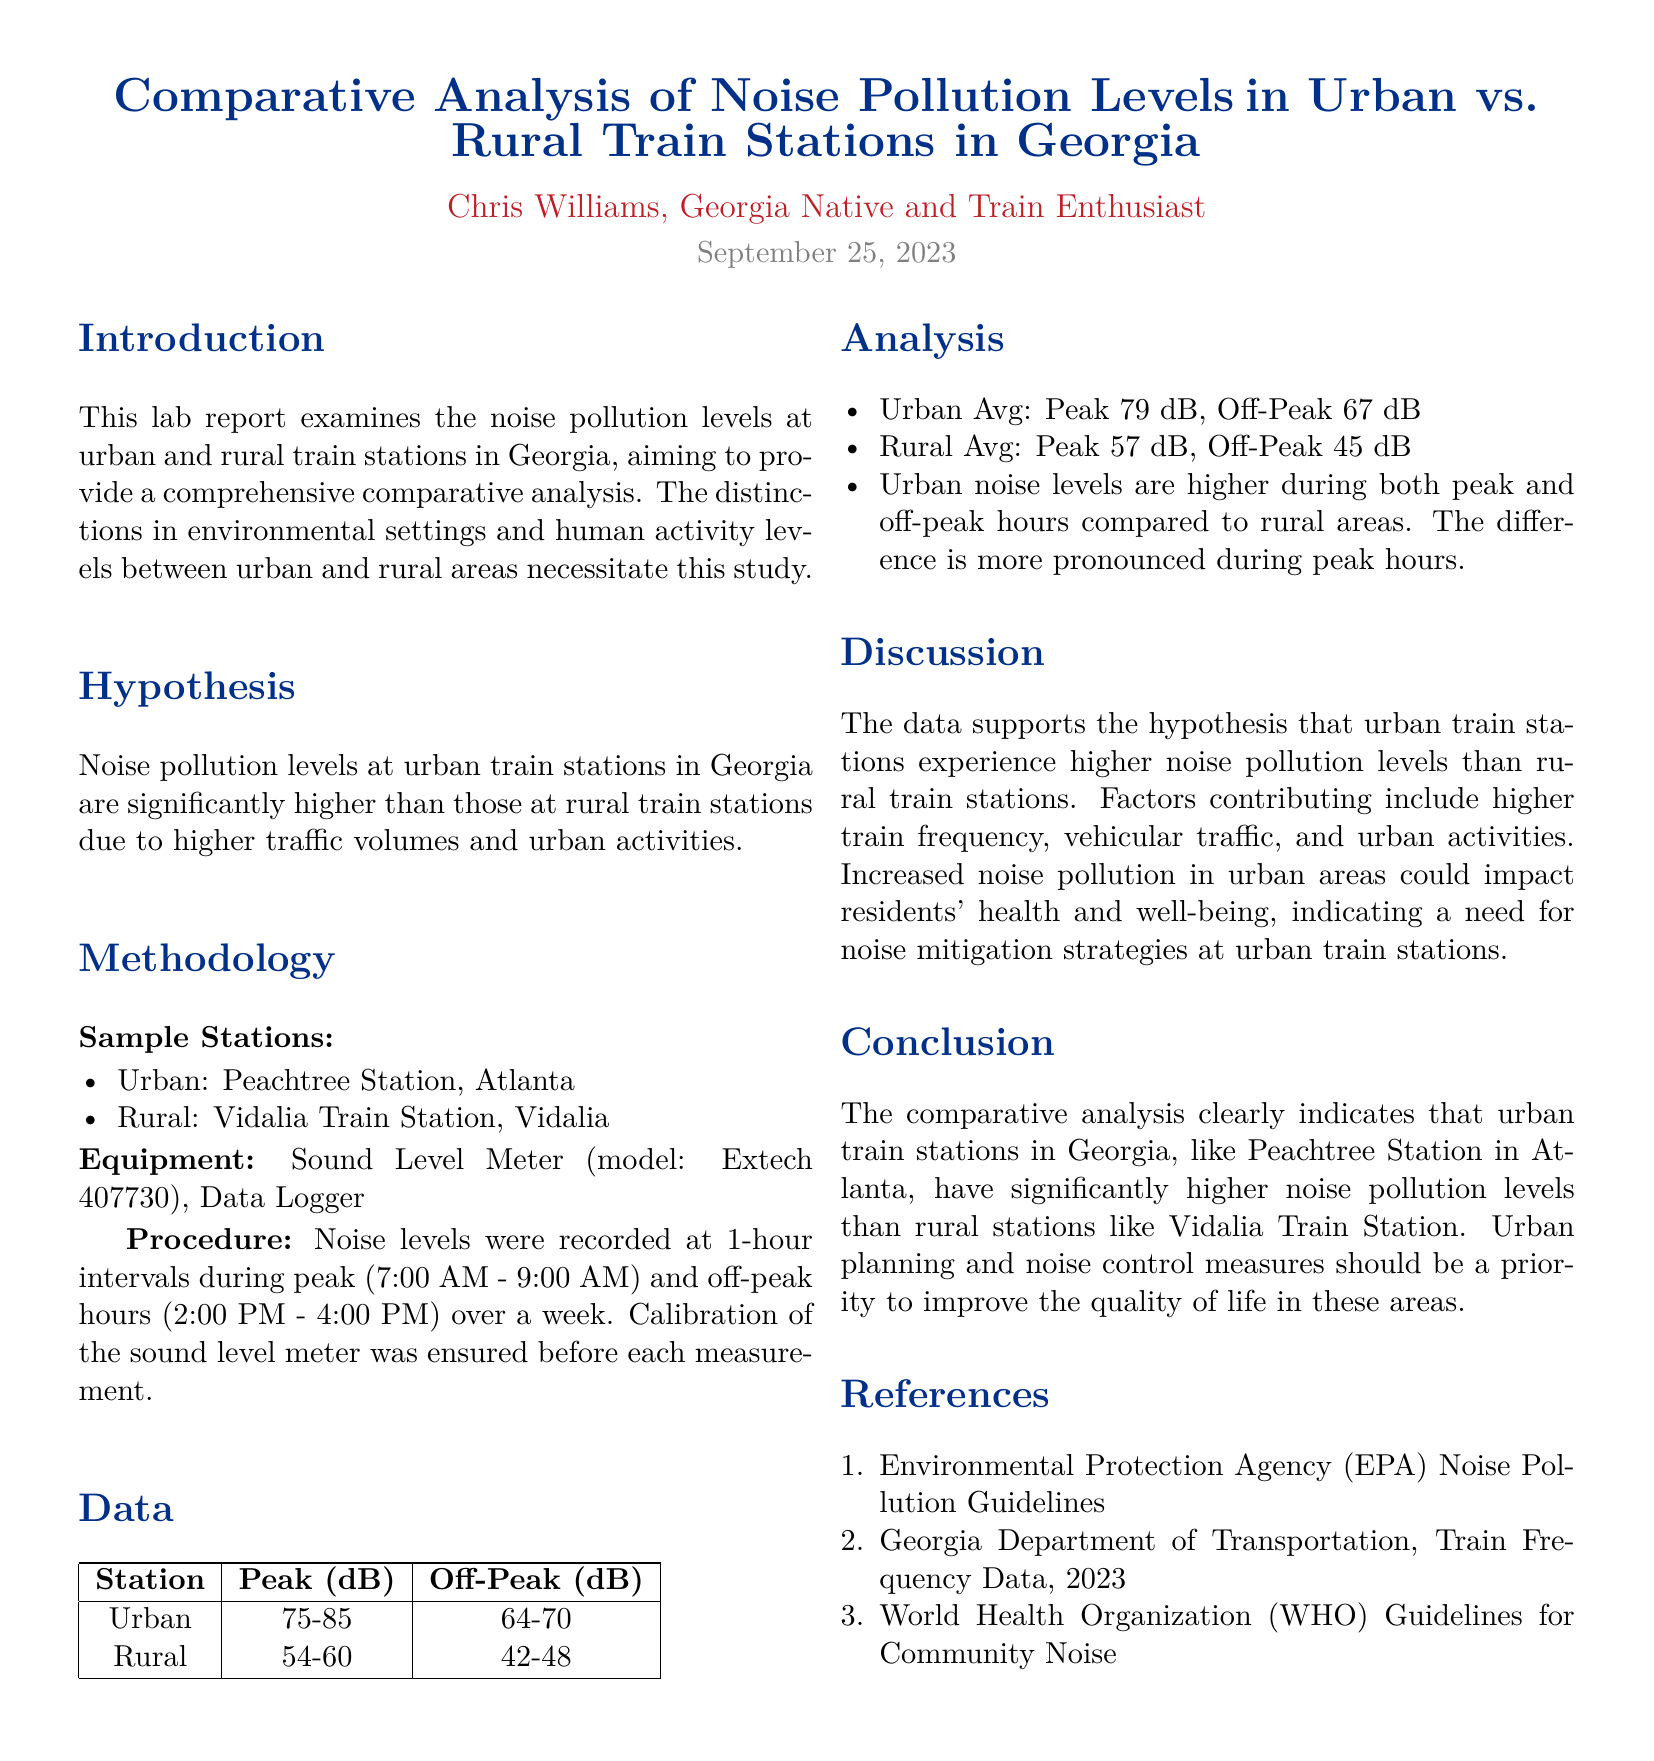What is the title of the lab report? The title summarizes the main focus of the report on noise pollution levels in different train stations in Georgia.
Answer: Comparative Analysis of Noise Pollution Levels in Urban vs. Rural Train Stations in Georgia Who authored the lab report? The document lists the author at the top, indicating their identity and interest in trains.
Answer: Chris Williams What is the date of the lab report? The date in the document indicates when the report was completed.
Answer: September 25, 2023 What was the peak noise level recorded at urban stations? The document provides specific dB ranges under the Data section.
Answer: 75-85 What was the average off-peak noise level at rural stations? The average off-peak noise level is calculated based on the ranges provided in the Data section.
Answer: 42-48 Why do urban train stations have higher noise pollution levels? The reasoning is mentioned in the Discussion section, listing the contributing factors to urban noise levels.
Answer: Higher train frequency, vehicular traffic, and urban activities What methodology was used for collecting data? It is outlined in the Methodology section, defining how the measurements were taken.
Answer: Sound level meter and data logger What is one recommendation made in the report? The Conclusion suggests an action based on the findings of the study.
Answer: Noise control measures What are the peak noise levels recorded at rural stations? The Data section presents these specific levels for comparison.
Answer: 54-60 